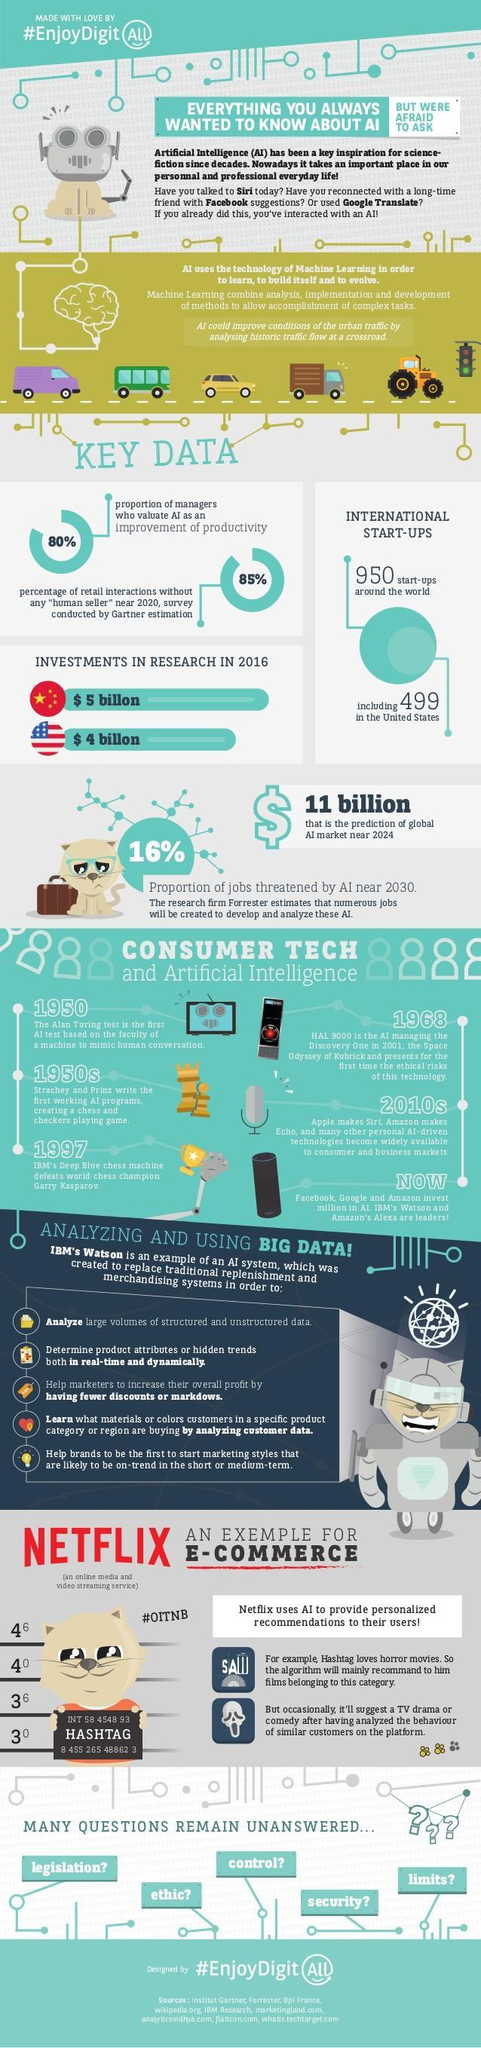What proportion of jobs are threatened by artificial intelligence by 2030?
Answer the question with a short phrase. 16% Who developed Siri? Apple What is China's investment in AI? $ 5 billion What was the first working AI program? Chess and checkers playing game What is the percentage of retail interactions without human sellers in 2020? 85% How many non-American startups are there around the world? 401 What is America's investment in artificial intelligence? $4 billion Who developed Alexa? Amazon Who has invested more in artificial intelligence, America or China? China What percentage of of managers consider it necessary to have AI for improvement of productivity? 80% Which AI program defeated Garry Kasparov and who developed it? Deep blue chess machine, IBM Who developed the Watson assistant? IBM Who wrote the first AI working program and when? Strachey and Prinz, 1950s Which was the first test to study the ability of a machine to mimic human conversation? Alan Turing test What data would be sufficient for AI to improve the urban traffic? Historic traffic flow at a crossroad What is the prediction of the Global artificial intelligence market in 2024? $ 11 billion How many images of vehicles are shown here? 5 How many "uncertainties" relating to artificial intelligence are mentioned here? 5 When was Siri and Echo and many other ai-driven technologies made available to people? 2010s 